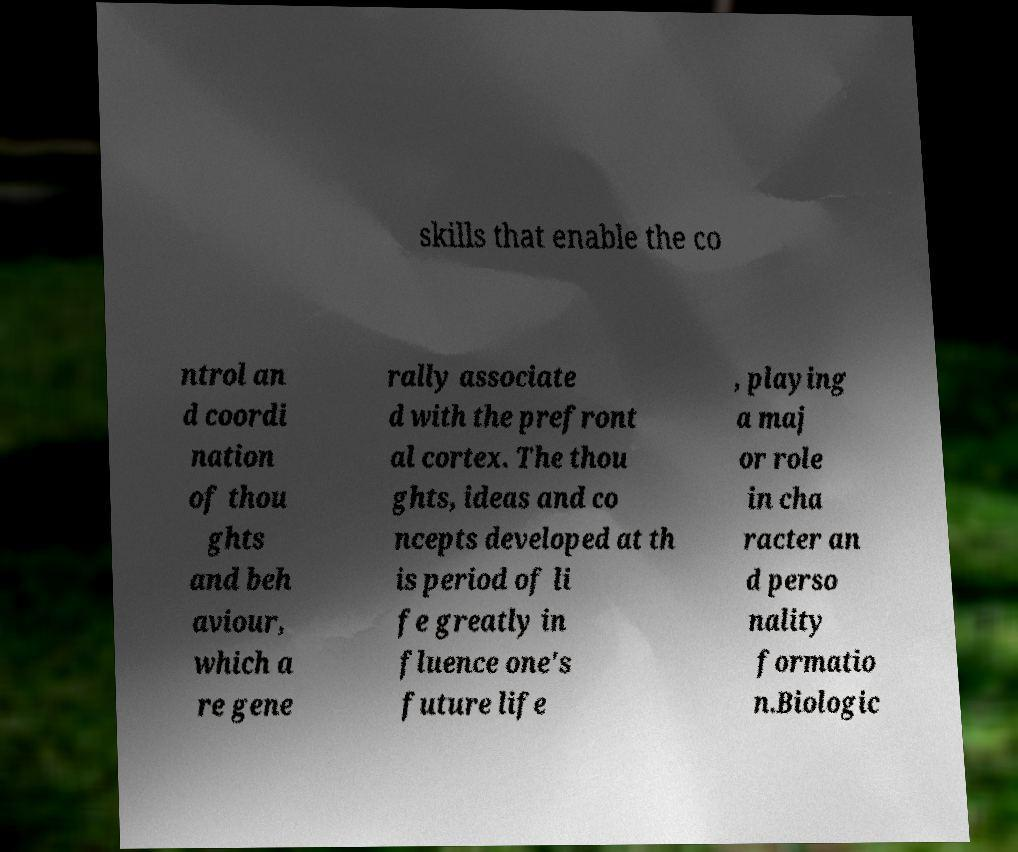Can you read and provide the text displayed in the image?This photo seems to have some interesting text. Can you extract and type it out for me? skills that enable the co ntrol an d coordi nation of thou ghts and beh aviour, which a re gene rally associate d with the prefront al cortex. The thou ghts, ideas and co ncepts developed at th is period of li fe greatly in fluence one's future life , playing a maj or role in cha racter an d perso nality formatio n.Biologic 